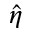<formula> <loc_0><loc_0><loc_500><loc_500>\hat { \eta }</formula> 